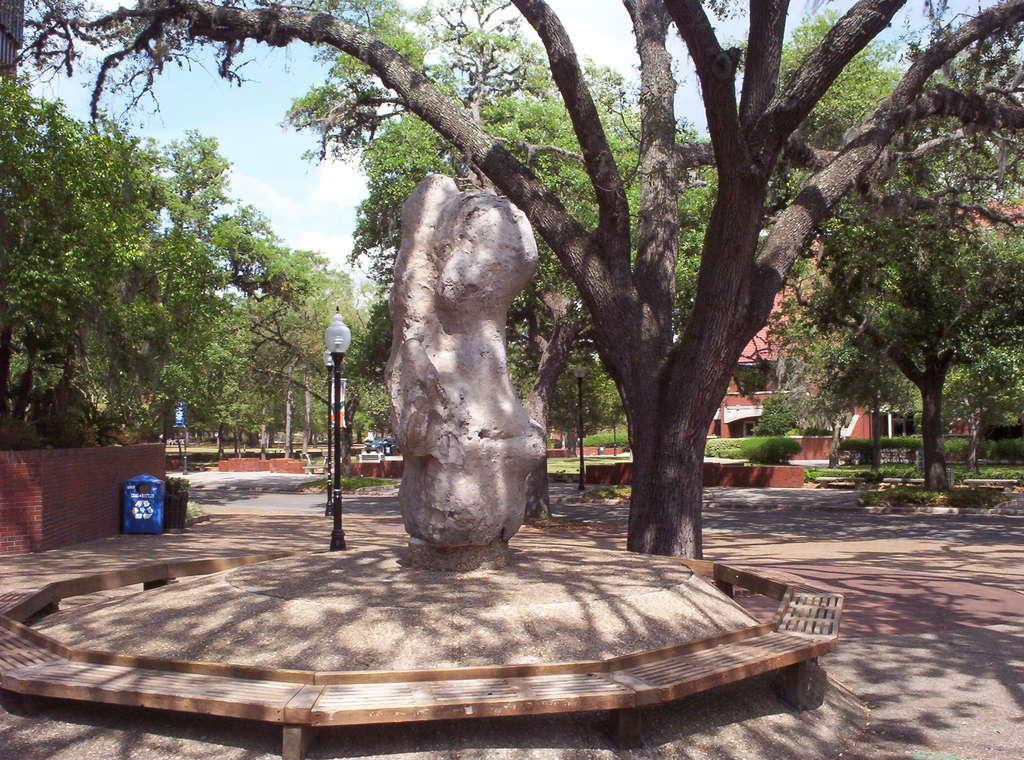Describe this image in one or two sentences. In this image I can see a sculpture in the middle, behind that there are so many trees, poles and building. 